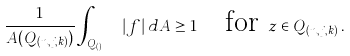<formula> <loc_0><loc_0><loc_500><loc_500>\frac { 1 } { A ( Q _ { ( n , j , k ) } ) } \int _ { Q _ { ( n , j , k ) } } | f | \, d A \geq 1 \quad \text {for } z \in Q _ { ( n , j , k ) } \, .</formula> 